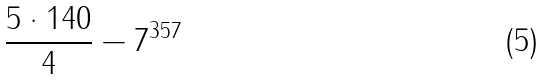<formula> <loc_0><loc_0><loc_500><loc_500>\frac { 5 \cdot 1 4 0 } { 4 } - 7 ^ { 3 5 7 }</formula> 